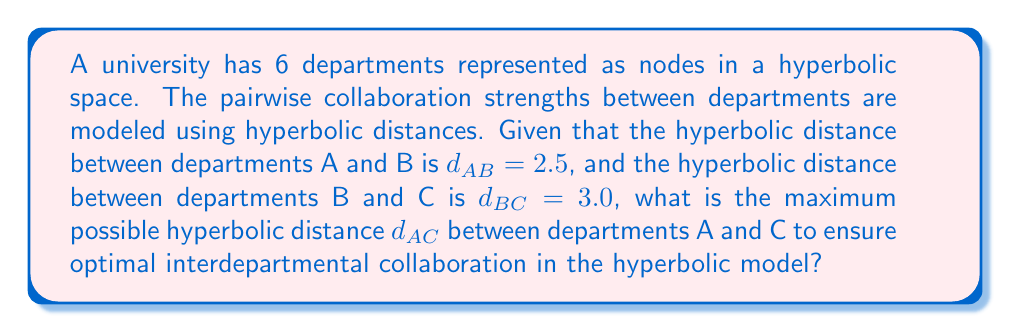Can you answer this question? To solve this problem, we need to use the hyperbolic triangle inequality theorem in the Poincaré disk model of hyperbolic geometry. The steps are as follows:

1. Recall the hyperbolic triangle inequality: For any three points A, B, and C in hyperbolic space, we have:

   $$\cosh(d_{AC}) \leq \cosh(d_{AB})\cosh(d_{BC}) + \sinh(d_{AB})\sinh(d_{BC})$$

2. We want to find the maximum possible value of $d_{AC}$, so we'll use the equality case:

   $$\cosh(d_{AC}) = \cosh(d_{AB})\cosh(d_{BC}) + \sinh(d_{AB})\sinh(d_{BC})$$

3. Given: $d_{AB} = 2.5$ and $d_{BC} = 3.0$

4. Calculate $\cosh(d_{AB})$ and $\sinh(d_{AB})$:
   $$\cosh(2.5) \approx 6.1322$$
   $$\sinh(2.5) \approx 6.0502$$

5. Calculate $\cosh(d_{BC})$ and $\sinh(d_{BC})$:
   $$\cosh(3.0) \approx 10.0677$$
   $$\sinh(3.0) \approx 10.0179$$

6. Substitute these values into the equality:
   $$\cosh(d_{AC}) = (6.1322)(10.0677) + (6.0502)(10.0179) \approx 122.1018$$

7. To find $d_{AC}$, we need to apply the inverse hyperbolic cosine function:
   $$d_{AC} = \text{arccosh}(122.1018) \approx 5.4036$$

8. Round to two decimal places for practical use in budget optimization:
   $$d_{AC} \approx 5.40$$

This maximum distance ensures optimal collaboration while maintaining the hyperbolic network structure.
Answer: $5.40$ 